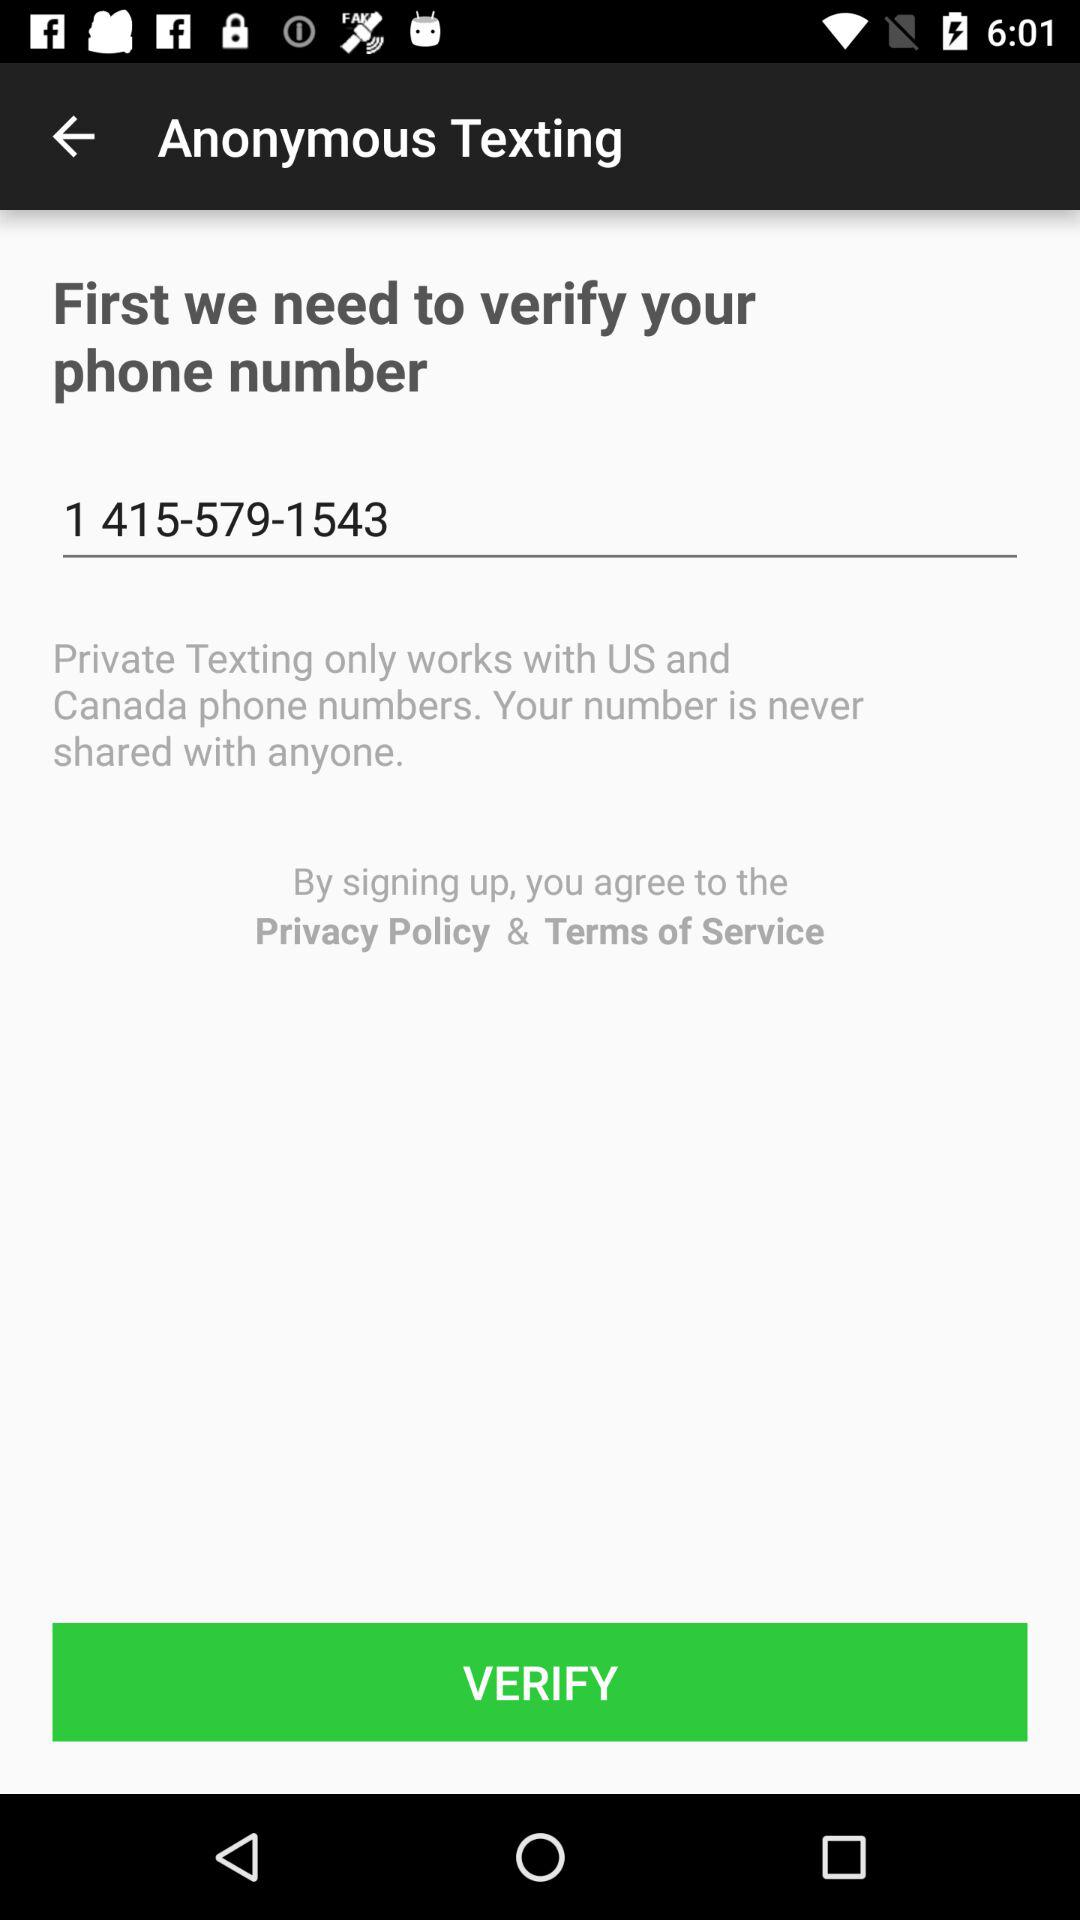What is the phone number? The phone number is 1 415-579-1543. 